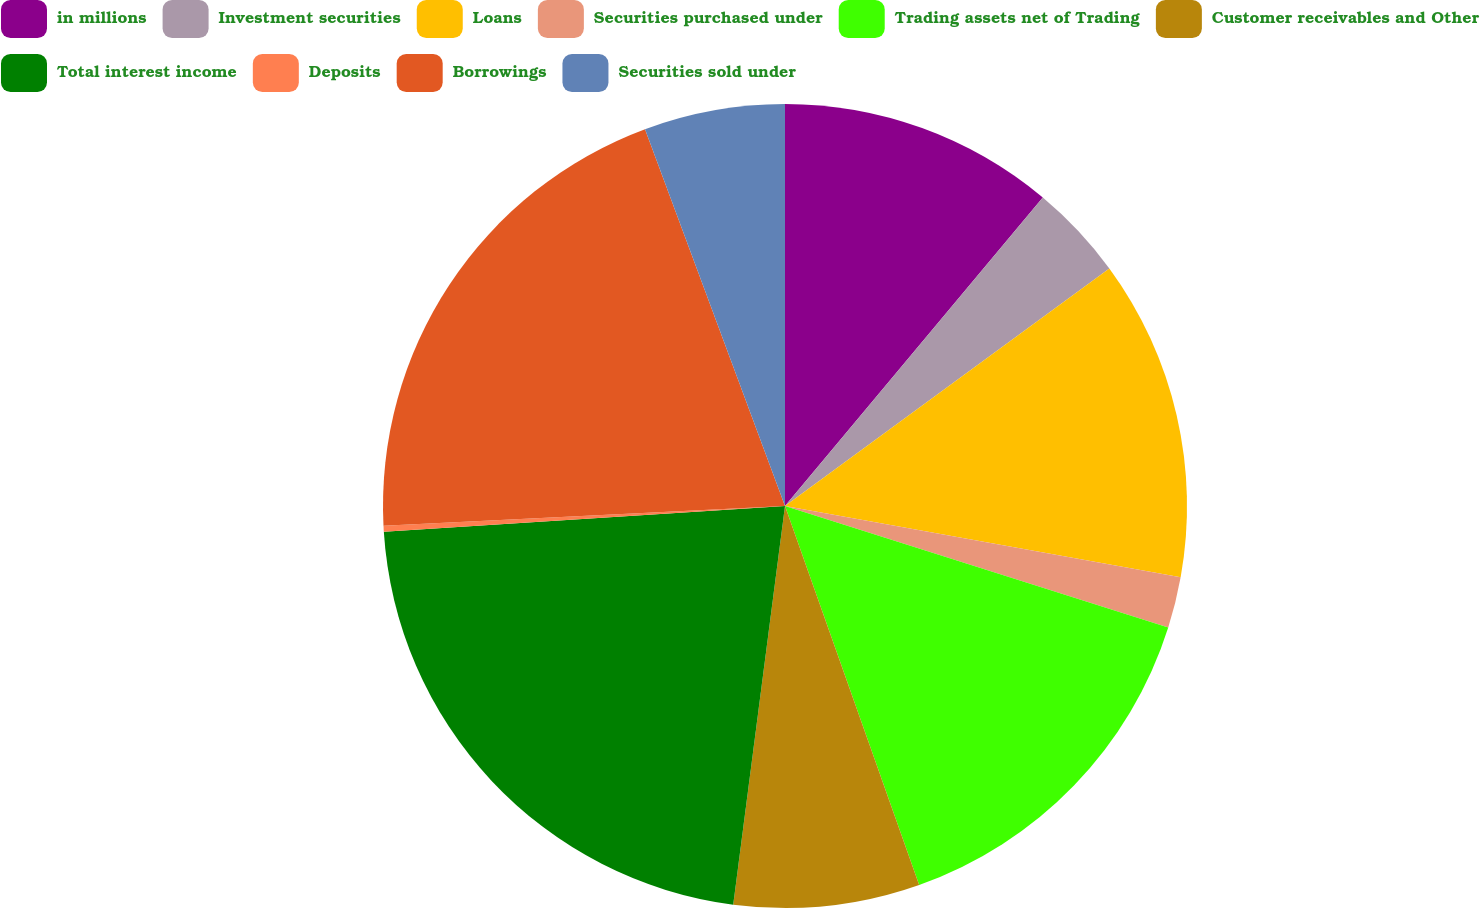<chart> <loc_0><loc_0><loc_500><loc_500><pie_chart><fcel>in millions<fcel>Investment securities<fcel>Loans<fcel>Securities purchased under<fcel>Trading assets net of Trading<fcel>Customer receivables and Other<fcel>Total interest income<fcel>Deposits<fcel>Borrowings<fcel>Securities sold under<nl><fcel>11.08%<fcel>3.86%<fcel>12.89%<fcel>2.05%<fcel>14.7%<fcel>7.47%<fcel>21.92%<fcel>0.24%<fcel>20.12%<fcel>5.66%<nl></chart> 